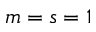<formula> <loc_0><loc_0><loc_500><loc_500>m = s = 1</formula> 